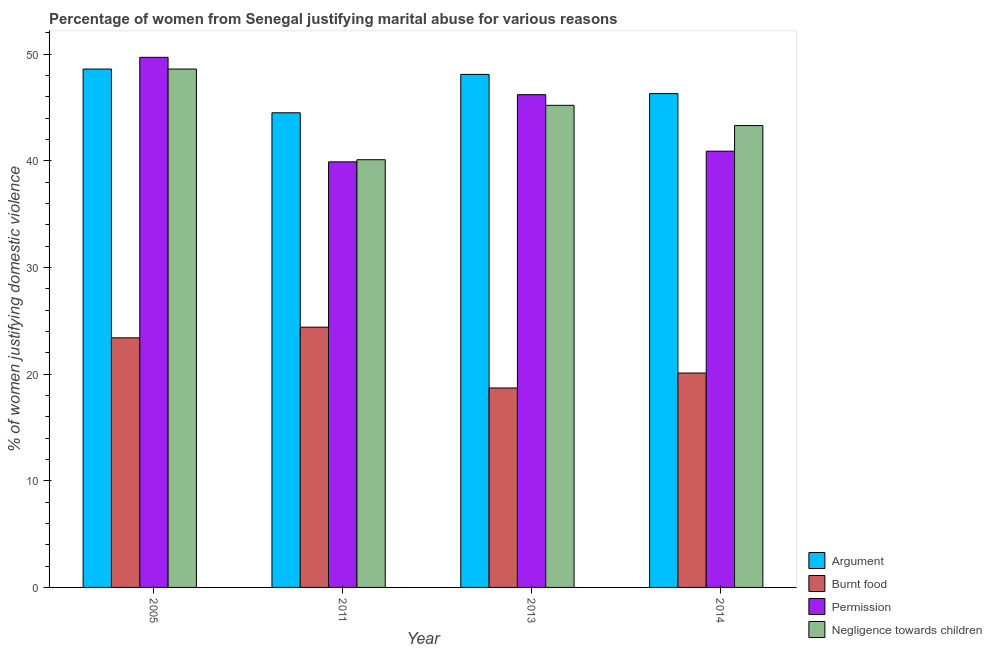Are the number of bars per tick equal to the number of legend labels?
Your answer should be compact. Yes. In how many cases, is the number of bars for a given year not equal to the number of legend labels?
Make the answer very short. 0. What is the percentage of women justifying abuse in the case of an argument in 2005?
Offer a terse response. 48.6. Across all years, what is the maximum percentage of women justifying abuse for burning food?
Your answer should be very brief. 24.4. Across all years, what is the minimum percentage of women justifying abuse for showing negligence towards children?
Provide a short and direct response. 40.1. In which year was the percentage of women justifying abuse for burning food maximum?
Ensure brevity in your answer.  2011. What is the total percentage of women justifying abuse in the case of an argument in the graph?
Provide a succinct answer. 187.5. What is the difference between the percentage of women justifying abuse for going without permission in 2013 and that in 2014?
Your answer should be compact. 5.3. What is the difference between the percentage of women justifying abuse for showing negligence towards children in 2005 and the percentage of women justifying abuse for burning food in 2013?
Your response must be concise. 3.4. What is the average percentage of women justifying abuse for burning food per year?
Ensure brevity in your answer.  21.65. What is the ratio of the percentage of women justifying abuse for going without permission in 2005 to that in 2011?
Make the answer very short. 1.25. Is the difference between the percentage of women justifying abuse in the case of an argument in 2011 and 2013 greater than the difference between the percentage of women justifying abuse for burning food in 2011 and 2013?
Provide a short and direct response. No. What is the difference between the highest and the second highest percentage of women justifying abuse for burning food?
Offer a very short reply. 1. In how many years, is the percentage of women justifying abuse for showing negligence towards children greater than the average percentage of women justifying abuse for showing negligence towards children taken over all years?
Provide a short and direct response. 2. Is it the case that in every year, the sum of the percentage of women justifying abuse for showing negligence towards children and percentage of women justifying abuse in the case of an argument is greater than the sum of percentage of women justifying abuse for burning food and percentage of women justifying abuse for going without permission?
Give a very brief answer. No. What does the 3rd bar from the left in 2014 represents?
Provide a succinct answer. Permission. What does the 2nd bar from the right in 2013 represents?
Offer a terse response. Permission. Is it the case that in every year, the sum of the percentage of women justifying abuse in the case of an argument and percentage of women justifying abuse for burning food is greater than the percentage of women justifying abuse for going without permission?
Your answer should be very brief. Yes. Are all the bars in the graph horizontal?
Your answer should be very brief. No. How many years are there in the graph?
Your response must be concise. 4. Are the values on the major ticks of Y-axis written in scientific E-notation?
Offer a very short reply. No. Does the graph contain any zero values?
Provide a short and direct response. No. Where does the legend appear in the graph?
Your answer should be compact. Bottom right. What is the title of the graph?
Give a very brief answer. Percentage of women from Senegal justifying marital abuse for various reasons. What is the label or title of the X-axis?
Your answer should be compact. Year. What is the label or title of the Y-axis?
Your answer should be very brief. % of women justifying domestic violence. What is the % of women justifying domestic violence of Argument in 2005?
Your response must be concise. 48.6. What is the % of women justifying domestic violence of Burnt food in 2005?
Offer a very short reply. 23.4. What is the % of women justifying domestic violence of Permission in 2005?
Offer a very short reply. 49.7. What is the % of women justifying domestic violence in Negligence towards children in 2005?
Your answer should be very brief. 48.6. What is the % of women justifying domestic violence in Argument in 2011?
Ensure brevity in your answer.  44.5. What is the % of women justifying domestic violence in Burnt food in 2011?
Give a very brief answer. 24.4. What is the % of women justifying domestic violence in Permission in 2011?
Offer a very short reply. 39.9. What is the % of women justifying domestic violence in Negligence towards children in 2011?
Provide a succinct answer. 40.1. What is the % of women justifying domestic violence in Argument in 2013?
Keep it short and to the point. 48.1. What is the % of women justifying domestic violence of Burnt food in 2013?
Your answer should be very brief. 18.7. What is the % of women justifying domestic violence in Permission in 2013?
Provide a short and direct response. 46.2. What is the % of women justifying domestic violence in Negligence towards children in 2013?
Your answer should be very brief. 45.2. What is the % of women justifying domestic violence of Argument in 2014?
Provide a succinct answer. 46.3. What is the % of women justifying domestic violence of Burnt food in 2014?
Offer a very short reply. 20.1. What is the % of women justifying domestic violence of Permission in 2014?
Your answer should be very brief. 40.9. What is the % of women justifying domestic violence of Negligence towards children in 2014?
Your response must be concise. 43.3. Across all years, what is the maximum % of women justifying domestic violence of Argument?
Provide a succinct answer. 48.6. Across all years, what is the maximum % of women justifying domestic violence in Burnt food?
Give a very brief answer. 24.4. Across all years, what is the maximum % of women justifying domestic violence in Permission?
Offer a very short reply. 49.7. Across all years, what is the maximum % of women justifying domestic violence in Negligence towards children?
Make the answer very short. 48.6. Across all years, what is the minimum % of women justifying domestic violence of Argument?
Ensure brevity in your answer.  44.5. Across all years, what is the minimum % of women justifying domestic violence in Permission?
Ensure brevity in your answer.  39.9. Across all years, what is the minimum % of women justifying domestic violence in Negligence towards children?
Provide a succinct answer. 40.1. What is the total % of women justifying domestic violence in Argument in the graph?
Your answer should be compact. 187.5. What is the total % of women justifying domestic violence in Burnt food in the graph?
Provide a short and direct response. 86.6. What is the total % of women justifying domestic violence of Permission in the graph?
Provide a succinct answer. 176.7. What is the total % of women justifying domestic violence in Negligence towards children in the graph?
Give a very brief answer. 177.2. What is the difference between the % of women justifying domestic violence of Argument in 2005 and that in 2011?
Give a very brief answer. 4.1. What is the difference between the % of women justifying domestic violence of Burnt food in 2005 and that in 2011?
Ensure brevity in your answer.  -1. What is the difference between the % of women justifying domestic violence of Permission in 2005 and that in 2011?
Give a very brief answer. 9.8. What is the difference between the % of women justifying domestic violence in Negligence towards children in 2005 and that in 2011?
Provide a short and direct response. 8.5. What is the difference between the % of women justifying domestic violence of Burnt food in 2005 and that in 2013?
Offer a terse response. 4.7. What is the difference between the % of women justifying domestic violence in Permission in 2005 and that in 2013?
Offer a very short reply. 3.5. What is the difference between the % of women justifying domestic violence of Argument in 2005 and that in 2014?
Ensure brevity in your answer.  2.3. What is the difference between the % of women justifying domestic violence of Burnt food in 2005 and that in 2014?
Offer a terse response. 3.3. What is the difference between the % of women justifying domestic violence of Burnt food in 2011 and that in 2013?
Keep it short and to the point. 5.7. What is the difference between the % of women justifying domestic violence in Permission in 2011 and that in 2013?
Your answer should be compact. -6.3. What is the difference between the % of women justifying domestic violence in Burnt food in 2011 and that in 2014?
Provide a short and direct response. 4.3. What is the difference between the % of women justifying domestic violence in Permission in 2011 and that in 2014?
Offer a very short reply. -1. What is the difference between the % of women justifying domestic violence in Burnt food in 2013 and that in 2014?
Your response must be concise. -1.4. What is the difference between the % of women justifying domestic violence in Permission in 2013 and that in 2014?
Keep it short and to the point. 5.3. What is the difference between the % of women justifying domestic violence of Negligence towards children in 2013 and that in 2014?
Provide a succinct answer. 1.9. What is the difference between the % of women justifying domestic violence of Argument in 2005 and the % of women justifying domestic violence of Burnt food in 2011?
Make the answer very short. 24.2. What is the difference between the % of women justifying domestic violence of Argument in 2005 and the % of women justifying domestic violence of Permission in 2011?
Your answer should be compact. 8.7. What is the difference between the % of women justifying domestic violence in Argument in 2005 and the % of women justifying domestic violence in Negligence towards children in 2011?
Ensure brevity in your answer.  8.5. What is the difference between the % of women justifying domestic violence in Burnt food in 2005 and the % of women justifying domestic violence in Permission in 2011?
Keep it short and to the point. -16.5. What is the difference between the % of women justifying domestic violence in Burnt food in 2005 and the % of women justifying domestic violence in Negligence towards children in 2011?
Provide a succinct answer. -16.7. What is the difference between the % of women justifying domestic violence of Permission in 2005 and the % of women justifying domestic violence of Negligence towards children in 2011?
Your answer should be compact. 9.6. What is the difference between the % of women justifying domestic violence of Argument in 2005 and the % of women justifying domestic violence of Burnt food in 2013?
Offer a terse response. 29.9. What is the difference between the % of women justifying domestic violence in Argument in 2005 and the % of women justifying domestic violence in Negligence towards children in 2013?
Your answer should be compact. 3.4. What is the difference between the % of women justifying domestic violence of Burnt food in 2005 and the % of women justifying domestic violence of Permission in 2013?
Provide a succinct answer. -22.8. What is the difference between the % of women justifying domestic violence in Burnt food in 2005 and the % of women justifying domestic violence in Negligence towards children in 2013?
Your answer should be very brief. -21.8. What is the difference between the % of women justifying domestic violence in Permission in 2005 and the % of women justifying domestic violence in Negligence towards children in 2013?
Your response must be concise. 4.5. What is the difference between the % of women justifying domestic violence of Argument in 2005 and the % of women justifying domestic violence of Burnt food in 2014?
Your answer should be very brief. 28.5. What is the difference between the % of women justifying domestic violence of Burnt food in 2005 and the % of women justifying domestic violence of Permission in 2014?
Provide a succinct answer. -17.5. What is the difference between the % of women justifying domestic violence in Burnt food in 2005 and the % of women justifying domestic violence in Negligence towards children in 2014?
Your response must be concise. -19.9. What is the difference between the % of women justifying domestic violence in Argument in 2011 and the % of women justifying domestic violence in Burnt food in 2013?
Give a very brief answer. 25.8. What is the difference between the % of women justifying domestic violence of Argument in 2011 and the % of women justifying domestic violence of Permission in 2013?
Make the answer very short. -1.7. What is the difference between the % of women justifying domestic violence of Burnt food in 2011 and the % of women justifying domestic violence of Permission in 2013?
Make the answer very short. -21.8. What is the difference between the % of women justifying domestic violence of Burnt food in 2011 and the % of women justifying domestic violence of Negligence towards children in 2013?
Offer a terse response. -20.8. What is the difference between the % of women justifying domestic violence of Permission in 2011 and the % of women justifying domestic violence of Negligence towards children in 2013?
Offer a very short reply. -5.3. What is the difference between the % of women justifying domestic violence of Argument in 2011 and the % of women justifying domestic violence of Burnt food in 2014?
Offer a very short reply. 24.4. What is the difference between the % of women justifying domestic violence in Argument in 2011 and the % of women justifying domestic violence in Negligence towards children in 2014?
Give a very brief answer. 1.2. What is the difference between the % of women justifying domestic violence in Burnt food in 2011 and the % of women justifying domestic violence in Permission in 2014?
Ensure brevity in your answer.  -16.5. What is the difference between the % of women justifying domestic violence of Burnt food in 2011 and the % of women justifying domestic violence of Negligence towards children in 2014?
Your response must be concise. -18.9. What is the difference between the % of women justifying domestic violence in Argument in 2013 and the % of women justifying domestic violence in Burnt food in 2014?
Your response must be concise. 28. What is the difference between the % of women justifying domestic violence of Burnt food in 2013 and the % of women justifying domestic violence of Permission in 2014?
Your answer should be very brief. -22.2. What is the difference between the % of women justifying domestic violence of Burnt food in 2013 and the % of women justifying domestic violence of Negligence towards children in 2014?
Ensure brevity in your answer.  -24.6. What is the average % of women justifying domestic violence of Argument per year?
Make the answer very short. 46.88. What is the average % of women justifying domestic violence in Burnt food per year?
Offer a terse response. 21.65. What is the average % of women justifying domestic violence in Permission per year?
Provide a succinct answer. 44.17. What is the average % of women justifying domestic violence of Negligence towards children per year?
Make the answer very short. 44.3. In the year 2005, what is the difference between the % of women justifying domestic violence in Argument and % of women justifying domestic violence in Burnt food?
Make the answer very short. 25.2. In the year 2005, what is the difference between the % of women justifying domestic violence of Argument and % of women justifying domestic violence of Permission?
Your answer should be compact. -1.1. In the year 2005, what is the difference between the % of women justifying domestic violence of Burnt food and % of women justifying domestic violence of Permission?
Make the answer very short. -26.3. In the year 2005, what is the difference between the % of women justifying domestic violence of Burnt food and % of women justifying domestic violence of Negligence towards children?
Offer a very short reply. -25.2. In the year 2011, what is the difference between the % of women justifying domestic violence in Argument and % of women justifying domestic violence in Burnt food?
Provide a succinct answer. 20.1. In the year 2011, what is the difference between the % of women justifying domestic violence in Argument and % of women justifying domestic violence in Permission?
Provide a succinct answer. 4.6. In the year 2011, what is the difference between the % of women justifying domestic violence in Burnt food and % of women justifying domestic violence in Permission?
Provide a succinct answer. -15.5. In the year 2011, what is the difference between the % of women justifying domestic violence in Burnt food and % of women justifying domestic violence in Negligence towards children?
Offer a very short reply. -15.7. In the year 2013, what is the difference between the % of women justifying domestic violence in Argument and % of women justifying domestic violence in Burnt food?
Offer a terse response. 29.4. In the year 2013, what is the difference between the % of women justifying domestic violence of Argument and % of women justifying domestic violence of Permission?
Offer a terse response. 1.9. In the year 2013, what is the difference between the % of women justifying domestic violence of Burnt food and % of women justifying domestic violence of Permission?
Provide a short and direct response. -27.5. In the year 2013, what is the difference between the % of women justifying domestic violence in Burnt food and % of women justifying domestic violence in Negligence towards children?
Your answer should be compact. -26.5. In the year 2013, what is the difference between the % of women justifying domestic violence in Permission and % of women justifying domestic violence in Negligence towards children?
Offer a terse response. 1. In the year 2014, what is the difference between the % of women justifying domestic violence of Argument and % of women justifying domestic violence of Burnt food?
Make the answer very short. 26.2. In the year 2014, what is the difference between the % of women justifying domestic violence in Argument and % of women justifying domestic violence in Permission?
Offer a terse response. 5.4. In the year 2014, what is the difference between the % of women justifying domestic violence of Argument and % of women justifying domestic violence of Negligence towards children?
Provide a short and direct response. 3. In the year 2014, what is the difference between the % of women justifying domestic violence of Burnt food and % of women justifying domestic violence of Permission?
Your response must be concise. -20.8. In the year 2014, what is the difference between the % of women justifying domestic violence in Burnt food and % of women justifying domestic violence in Negligence towards children?
Keep it short and to the point. -23.2. What is the ratio of the % of women justifying domestic violence of Argument in 2005 to that in 2011?
Keep it short and to the point. 1.09. What is the ratio of the % of women justifying domestic violence of Permission in 2005 to that in 2011?
Keep it short and to the point. 1.25. What is the ratio of the % of women justifying domestic violence in Negligence towards children in 2005 to that in 2011?
Provide a short and direct response. 1.21. What is the ratio of the % of women justifying domestic violence in Argument in 2005 to that in 2013?
Provide a succinct answer. 1.01. What is the ratio of the % of women justifying domestic violence of Burnt food in 2005 to that in 2013?
Ensure brevity in your answer.  1.25. What is the ratio of the % of women justifying domestic violence of Permission in 2005 to that in 2013?
Give a very brief answer. 1.08. What is the ratio of the % of women justifying domestic violence of Negligence towards children in 2005 to that in 2013?
Offer a very short reply. 1.08. What is the ratio of the % of women justifying domestic violence in Argument in 2005 to that in 2014?
Keep it short and to the point. 1.05. What is the ratio of the % of women justifying domestic violence of Burnt food in 2005 to that in 2014?
Provide a short and direct response. 1.16. What is the ratio of the % of women justifying domestic violence of Permission in 2005 to that in 2014?
Make the answer very short. 1.22. What is the ratio of the % of women justifying domestic violence of Negligence towards children in 2005 to that in 2014?
Your answer should be compact. 1.12. What is the ratio of the % of women justifying domestic violence of Argument in 2011 to that in 2013?
Your answer should be compact. 0.93. What is the ratio of the % of women justifying domestic violence of Burnt food in 2011 to that in 2013?
Provide a succinct answer. 1.3. What is the ratio of the % of women justifying domestic violence in Permission in 2011 to that in 2013?
Provide a succinct answer. 0.86. What is the ratio of the % of women justifying domestic violence of Negligence towards children in 2011 to that in 2013?
Keep it short and to the point. 0.89. What is the ratio of the % of women justifying domestic violence in Argument in 2011 to that in 2014?
Your answer should be compact. 0.96. What is the ratio of the % of women justifying domestic violence of Burnt food in 2011 to that in 2014?
Offer a very short reply. 1.21. What is the ratio of the % of women justifying domestic violence in Permission in 2011 to that in 2014?
Give a very brief answer. 0.98. What is the ratio of the % of women justifying domestic violence of Negligence towards children in 2011 to that in 2014?
Provide a short and direct response. 0.93. What is the ratio of the % of women justifying domestic violence in Argument in 2013 to that in 2014?
Your answer should be very brief. 1.04. What is the ratio of the % of women justifying domestic violence of Burnt food in 2013 to that in 2014?
Make the answer very short. 0.93. What is the ratio of the % of women justifying domestic violence in Permission in 2013 to that in 2014?
Your answer should be very brief. 1.13. What is the ratio of the % of women justifying domestic violence of Negligence towards children in 2013 to that in 2014?
Give a very brief answer. 1.04. What is the difference between the highest and the second highest % of women justifying domestic violence in Burnt food?
Offer a very short reply. 1. What is the difference between the highest and the second highest % of women justifying domestic violence in Permission?
Provide a succinct answer. 3.5. What is the difference between the highest and the second highest % of women justifying domestic violence of Negligence towards children?
Your answer should be compact. 3.4. What is the difference between the highest and the lowest % of women justifying domestic violence of Burnt food?
Keep it short and to the point. 5.7. 